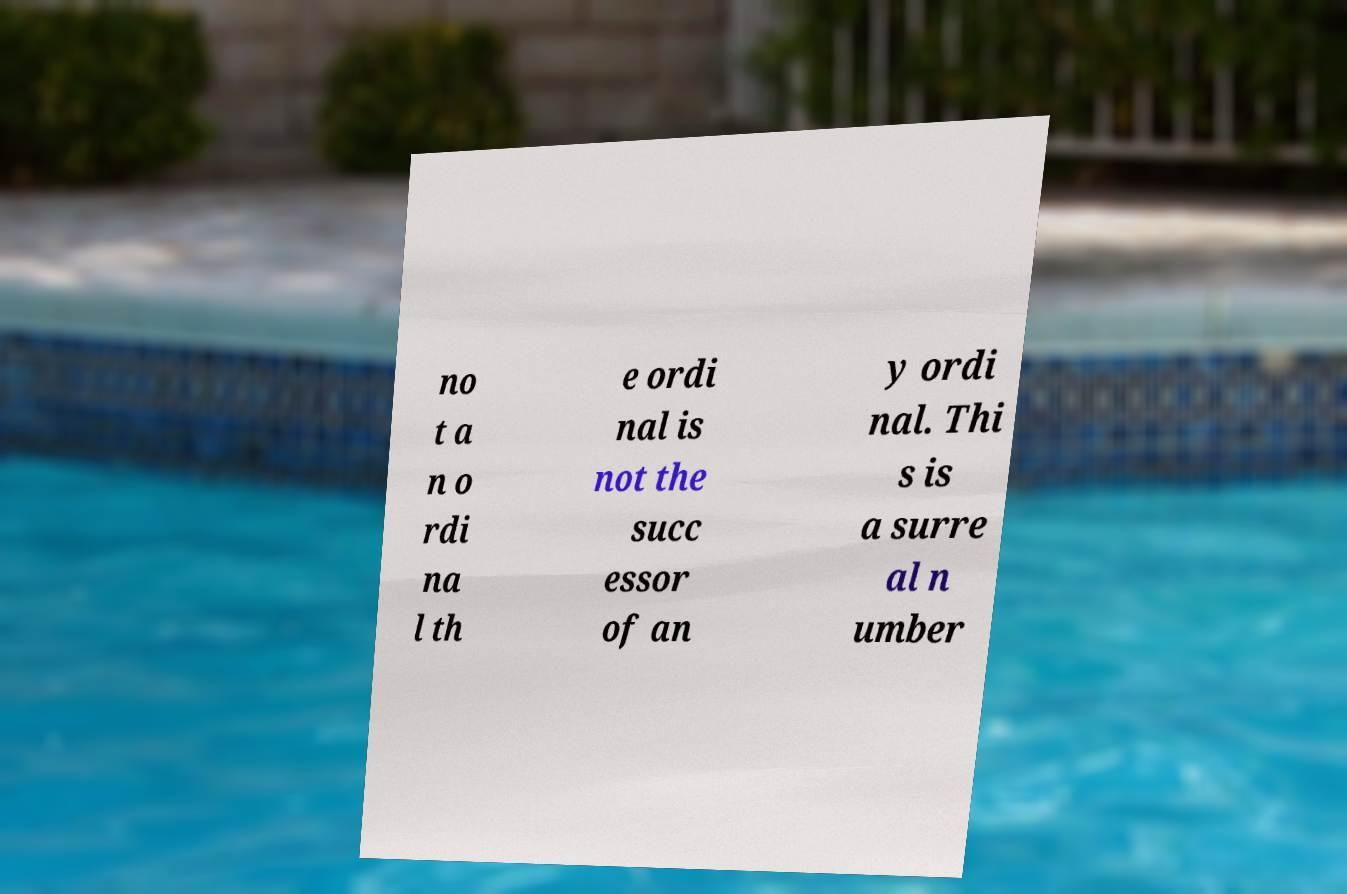Can you accurately transcribe the text from the provided image for me? no t a n o rdi na l th e ordi nal is not the succ essor of an y ordi nal. Thi s is a surre al n umber 